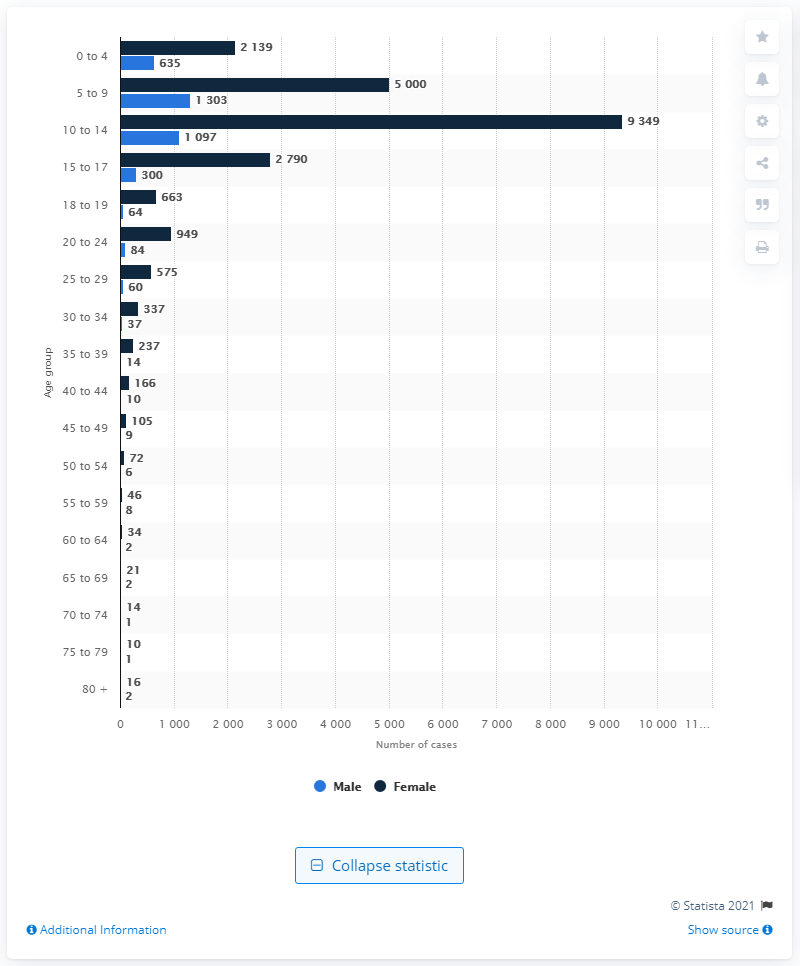Draw attention to some important aspects in this diagram. In 2019, a total of 9,349 alleged cases of sexual violence were reported in Colombia. 